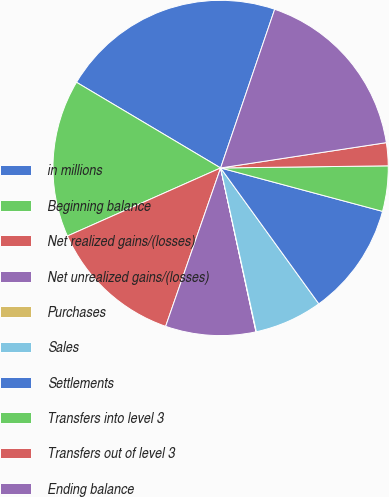Convert chart. <chart><loc_0><loc_0><loc_500><loc_500><pie_chart><fcel>in millions<fcel>Beginning balance<fcel>Net realized gains/(losses)<fcel>Net unrealized gains/(losses)<fcel>Purchases<fcel>Sales<fcel>Settlements<fcel>Transfers into level 3<fcel>Transfers out of level 3<fcel>Ending balance<nl><fcel>21.69%<fcel>15.19%<fcel>13.03%<fcel>8.7%<fcel>0.04%<fcel>6.54%<fcel>10.87%<fcel>4.37%<fcel>2.21%<fcel>17.36%<nl></chart> 